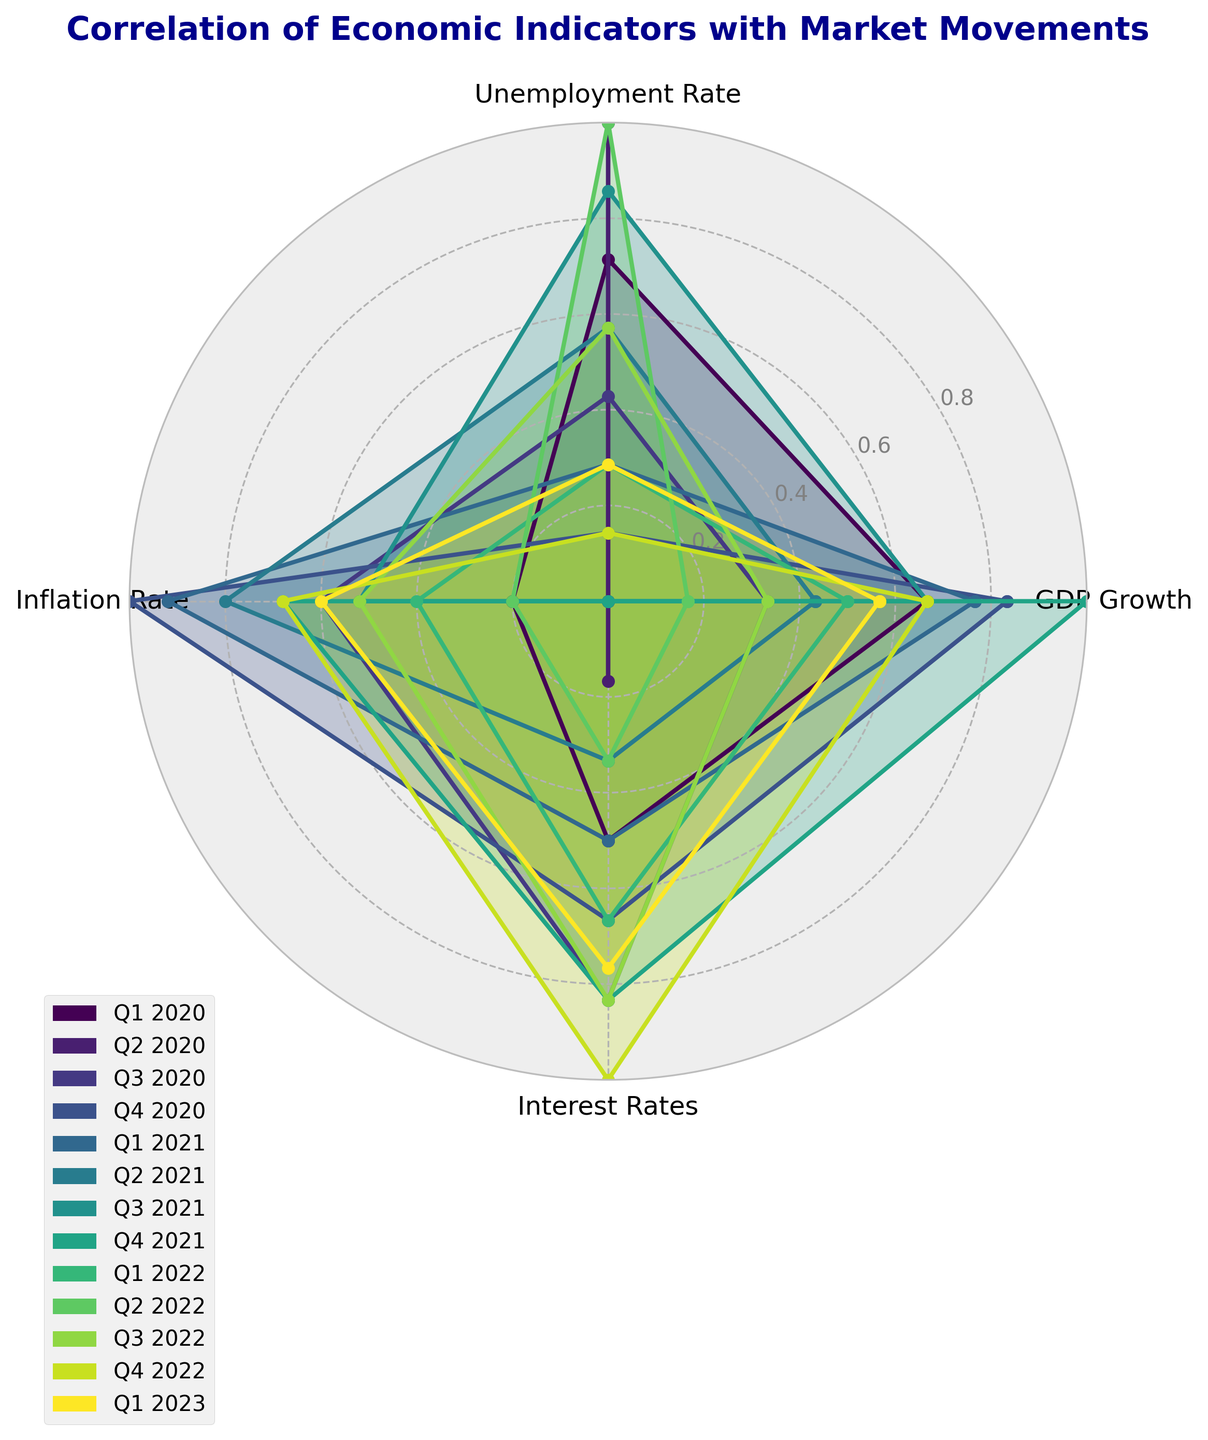What economic indicator shows the highest correlation with market movements in Q1 2023? Look at the line corresponding to Q1 2023 and identify the highest value among the indicators. The highest peak on the radar chart for Q1 2023 shows the value of GDP Growth.
Answer: GDP Growth Which economic indicator shows the lowest correlation with market movements in Q3 2022? Locate the line for Q3 2022 and look for the indicator with the shortest distance from the center. The lowest point on the radar chart for Q3 2022 shows the value of Unemployment Rate.
Answer: Unemployment Rate Between Q2 2020 and Q3 2020, which quarter shows a higher correlation for Inflation Rate? Compare the lengths of the radar lines corresponding to Inflation Rate for Q2 2020 and Q3 2020. The length for Q3 2020 is longer, indicating a higher correlation.
Answer: Q3 2020 What is the average correlation of Interest Rates over the periods? Find the Interest Rates values for each period, sum them up and divide by the number of periods. Values = [0.70, 0.60, 0.80, 0.75, 0.70, 0.65, 0.55, 0.80, 0.75, 0.65, 0.80, 0.85, 0.78], Sum = 8.98, Average = 8.98 / 13
Answer: 0.69 Which economic indicator has the highest variability in correlation with market movements across all periods? Assess the spread of values for each economic indicator. GDP Growth shows the highest variability, ranging from 0.65 to 0.95 across periods.
Answer: GDP Growth Does the Unemployment Rate generally show an increasing or decreasing trend in its correlation from Q2 2020 to Q4 2021? Observe the pattern of the points for Unemployment Rate from Q2 2020 to Q4 2021. The values decrease from Q2 2020 (0.85) to Q4 2021 (0.50), indicating a decreasing trend.
Answer: Decreasing Compare the overall correlation patterns of GDP Growth and Inflation Rate. Which one tends to have a higher correlation with market movements? Compare the values for GDP Growth and Inflation Rate across all periods. GDP Growth values are consistently higher than Inflation Rate values.
Answer: GDP Growth What is the difference in the correlation of GDP Growth between Q1 2020 and Q1 2022? Subtract the GDP Growth value for Q1 2020 (0.85) from the value for Q1 2022 (0.80). Difference = 0.85 - 0.80
Answer: 0.05 